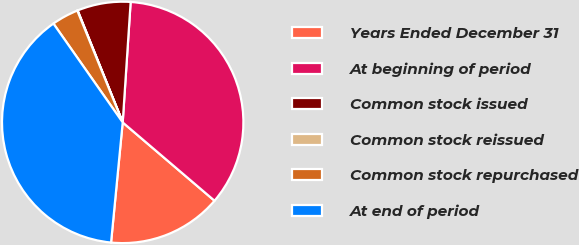<chart> <loc_0><loc_0><loc_500><loc_500><pie_chart><fcel>Years Ended December 31<fcel>At beginning of period<fcel>Common stock issued<fcel>Common stock reissued<fcel>Common stock repurchased<fcel>At end of period<nl><fcel>15.3%<fcel>35.19%<fcel>7.14%<fcel>0.05%<fcel>3.59%<fcel>38.73%<nl></chart> 